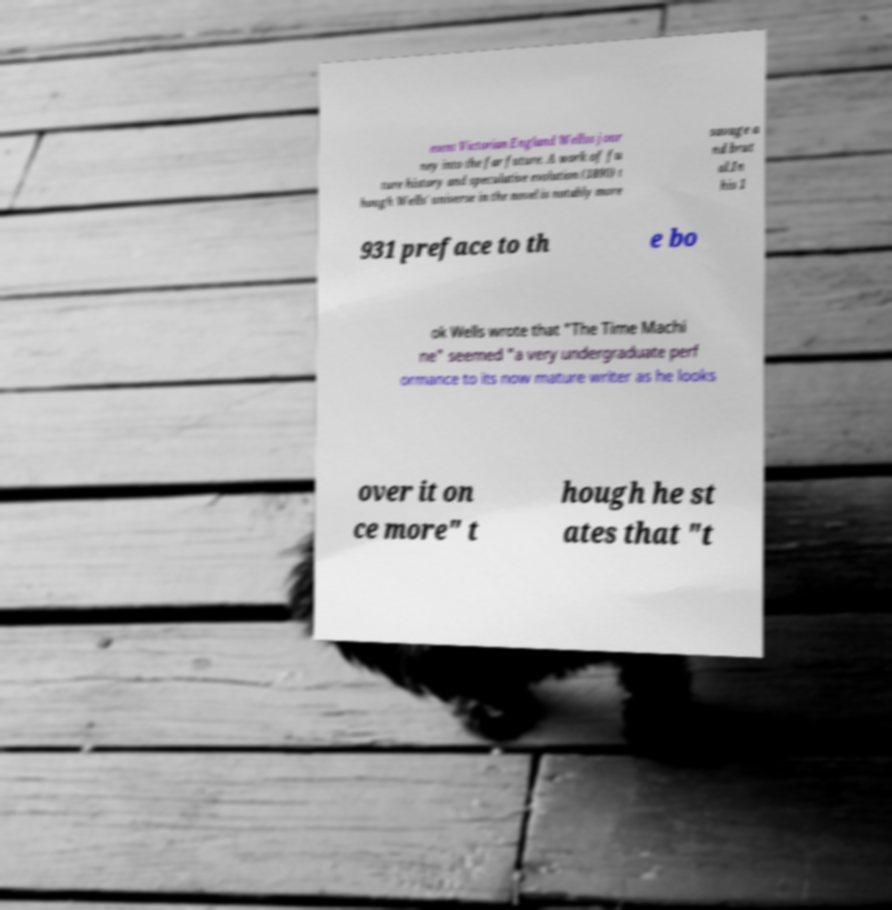Can you read and provide the text displayed in the image?This photo seems to have some interesting text. Can you extract and type it out for me? esent Victorian England Wellss jour ney into the far future. A work of fu ture history and speculative evolution (1890) t hough Wells' universe in the novel is notably more savage a nd brut al.In his 1 931 preface to th e bo ok Wells wrote that "The Time Machi ne" seemed "a very undergraduate perf ormance to its now mature writer as he looks over it on ce more" t hough he st ates that "t 